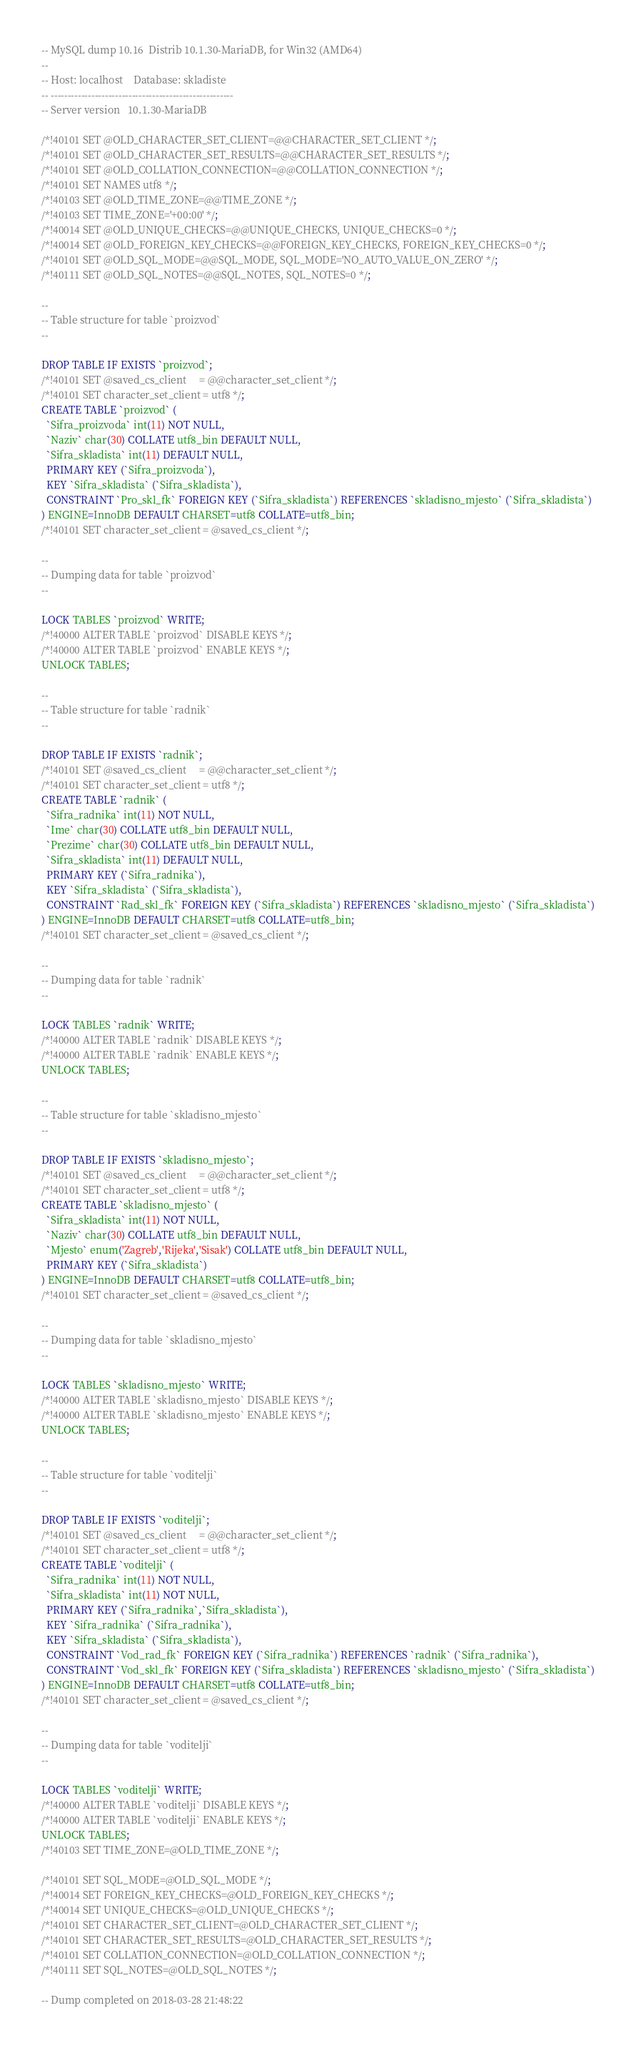<code> <loc_0><loc_0><loc_500><loc_500><_SQL_>-- MySQL dump 10.16  Distrib 10.1.30-MariaDB, for Win32 (AMD64)
--
-- Host: localhost    Database: skladiste
-- ------------------------------------------------------
-- Server version	10.1.30-MariaDB

/*!40101 SET @OLD_CHARACTER_SET_CLIENT=@@CHARACTER_SET_CLIENT */;
/*!40101 SET @OLD_CHARACTER_SET_RESULTS=@@CHARACTER_SET_RESULTS */;
/*!40101 SET @OLD_COLLATION_CONNECTION=@@COLLATION_CONNECTION */;
/*!40101 SET NAMES utf8 */;
/*!40103 SET @OLD_TIME_ZONE=@@TIME_ZONE */;
/*!40103 SET TIME_ZONE='+00:00' */;
/*!40014 SET @OLD_UNIQUE_CHECKS=@@UNIQUE_CHECKS, UNIQUE_CHECKS=0 */;
/*!40014 SET @OLD_FOREIGN_KEY_CHECKS=@@FOREIGN_KEY_CHECKS, FOREIGN_KEY_CHECKS=0 */;
/*!40101 SET @OLD_SQL_MODE=@@SQL_MODE, SQL_MODE='NO_AUTO_VALUE_ON_ZERO' */;
/*!40111 SET @OLD_SQL_NOTES=@@SQL_NOTES, SQL_NOTES=0 */;

--
-- Table structure for table `proizvod`
--

DROP TABLE IF EXISTS `proizvod`;
/*!40101 SET @saved_cs_client     = @@character_set_client */;
/*!40101 SET character_set_client = utf8 */;
CREATE TABLE `proizvod` (
  `Sifra_proizvoda` int(11) NOT NULL,
  `Naziv` char(30) COLLATE utf8_bin DEFAULT NULL,
  `Sifra_skladista` int(11) DEFAULT NULL,
  PRIMARY KEY (`Sifra_proizvoda`),
  KEY `Sifra_skladista` (`Sifra_skladista`),
  CONSTRAINT `Pro_skl_fk` FOREIGN KEY (`Sifra_skladista`) REFERENCES `skladisno_mjesto` (`Sifra_skladista`)
) ENGINE=InnoDB DEFAULT CHARSET=utf8 COLLATE=utf8_bin;
/*!40101 SET character_set_client = @saved_cs_client */;

--
-- Dumping data for table `proizvod`
--

LOCK TABLES `proizvod` WRITE;
/*!40000 ALTER TABLE `proizvod` DISABLE KEYS */;
/*!40000 ALTER TABLE `proizvod` ENABLE KEYS */;
UNLOCK TABLES;

--
-- Table structure for table `radnik`
--

DROP TABLE IF EXISTS `radnik`;
/*!40101 SET @saved_cs_client     = @@character_set_client */;
/*!40101 SET character_set_client = utf8 */;
CREATE TABLE `radnik` (
  `Sifra_radnika` int(11) NOT NULL,
  `Ime` char(30) COLLATE utf8_bin DEFAULT NULL,
  `Prezime` char(30) COLLATE utf8_bin DEFAULT NULL,
  `Sifra_skladista` int(11) DEFAULT NULL,
  PRIMARY KEY (`Sifra_radnika`),
  KEY `Sifra_skladista` (`Sifra_skladista`),
  CONSTRAINT `Rad_skl_fk` FOREIGN KEY (`Sifra_skladista`) REFERENCES `skladisno_mjesto` (`Sifra_skladista`)
) ENGINE=InnoDB DEFAULT CHARSET=utf8 COLLATE=utf8_bin;
/*!40101 SET character_set_client = @saved_cs_client */;

--
-- Dumping data for table `radnik`
--

LOCK TABLES `radnik` WRITE;
/*!40000 ALTER TABLE `radnik` DISABLE KEYS */;
/*!40000 ALTER TABLE `radnik` ENABLE KEYS */;
UNLOCK TABLES;

--
-- Table structure for table `skladisno_mjesto`
--

DROP TABLE IF EXISTS `skladisno_mjesto`;
/*!40101 SET @saved_cs_client     = @@character_set_client */;
/*!40101 SET character_set_client = utf8 */;
CREATE TABLE `skladisno_mjesto` (
  `Sifra_skladista` int(11) NOT NULL,
  `Naziv` char(30) COLLATE utf8_bin DEFAULT NULL,
  `Mjesto` enum('Zagreb','Rijeka','Sisak') COLLATE utf8_bin DEFAULT NULL,
  PRIMARY KEY (`Sifra_skladista`)
) ENGINE=InnoDB DEFAULT CHARSET=utf8 COLLATE=utf8_bin;
/*!40101 SET character_set_client = @saved_cs_client */;

--
-- Dumping data for table `skladisno_mjesto`
--

LOCK TABLES `skladisno_mjesto` WRITE;
/*!40000 ALTER TABLE `skladisno_mjesto` DISABLE KEYS */;
/*!40000 ALTER TABLE `skladisno_mjesto` ENABLE KEYS */;
UNLOCK TABLES;

--
-- Table structure for table `voditelji`
--

DROP TABLE IF EXISTS `voditelji`;
/*!40101 SET @saved_cs_client     = @@character_set_client */;
/*!40101 SET character_set_client = utf8 */;
CREATE TABLE `voditelji` (
  `Sifra_radnika` int(11) NOT NULL,
  `Sifra_skladista` int(11) NOT NULL,
  PRIMARY KEY (`Sifra_radnika`,`Sifra_skladista`),
  KEY `Sifra_radnika` (`Sifra_radnika`),
  KEY `Sifra_skladista` (`Sifra_skladista`),
  CONSTRAINT `Vod_rad_fk` FOREIGN KEY (`Sifra_radnika`) REFERENCES `radnik` (`Sifra_radnika`),
  CONSTRAINT `Vod_skl_fk` FOREIGN KEY (`Sifra_skladista`) REFERENCES `skladisno_mjesto` (`Sifra_skladista`)
) ENGINE=InnoDB DEFAULT CHARSET=utf8 COLLATE=utf8_bin;
/*!40101 SET character_set_client = @saved_cs_client */;

--
-- Dumping data for table `voditelji`
--

LOCK TABLES `voditelji` WRITE;
/*!40000 ALTER TABLE `voditelji` DISABLE KEYS */;
/*!40000 ALTER TABLE `voditelji` ENABLE KEYS */;
UNLOCK TABLES;
/*!40103 SET TIME_ZONE=@OLD_TIME_ZONE */;

/*!40101 SET SQL_MODE=@OLD_SQL_MODE */;
/*!40014 SET FOREIGN_KEY_CHECKS=@OLD_FOREIGN_KEY_CHECKS */;
/*!40014 SET UNIQUE_CHECKS=@OLD_UNIQUE_CHECKS */;
/*!40101 SET CHARACTER_SET_CLIENT=@OLD_CHARACTER_SET_CLIENT */;
/*!40101 SET CHARACTER_SET_RESULTS=@OLD_CHARACTER_SET_RESULTS */;
/*!40101 SET COLLATION_CONNECTION=@OLD_COLLATION_CONNECTION */;
/*!40111 SET SQL_NOTES=@OLD_SQL_NOTES */;

-- Dump completed on 2018-03-28 21:48:22
</code> 